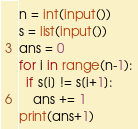<code> <loc_0><loc_0><loc_500><loc_500><_Python_>n = int(input())
s = list(input())
ans = 0
for i in range(n-1):
  if s[i] != s[i+1]:
    ans += 1
print(ans+1)</code> 